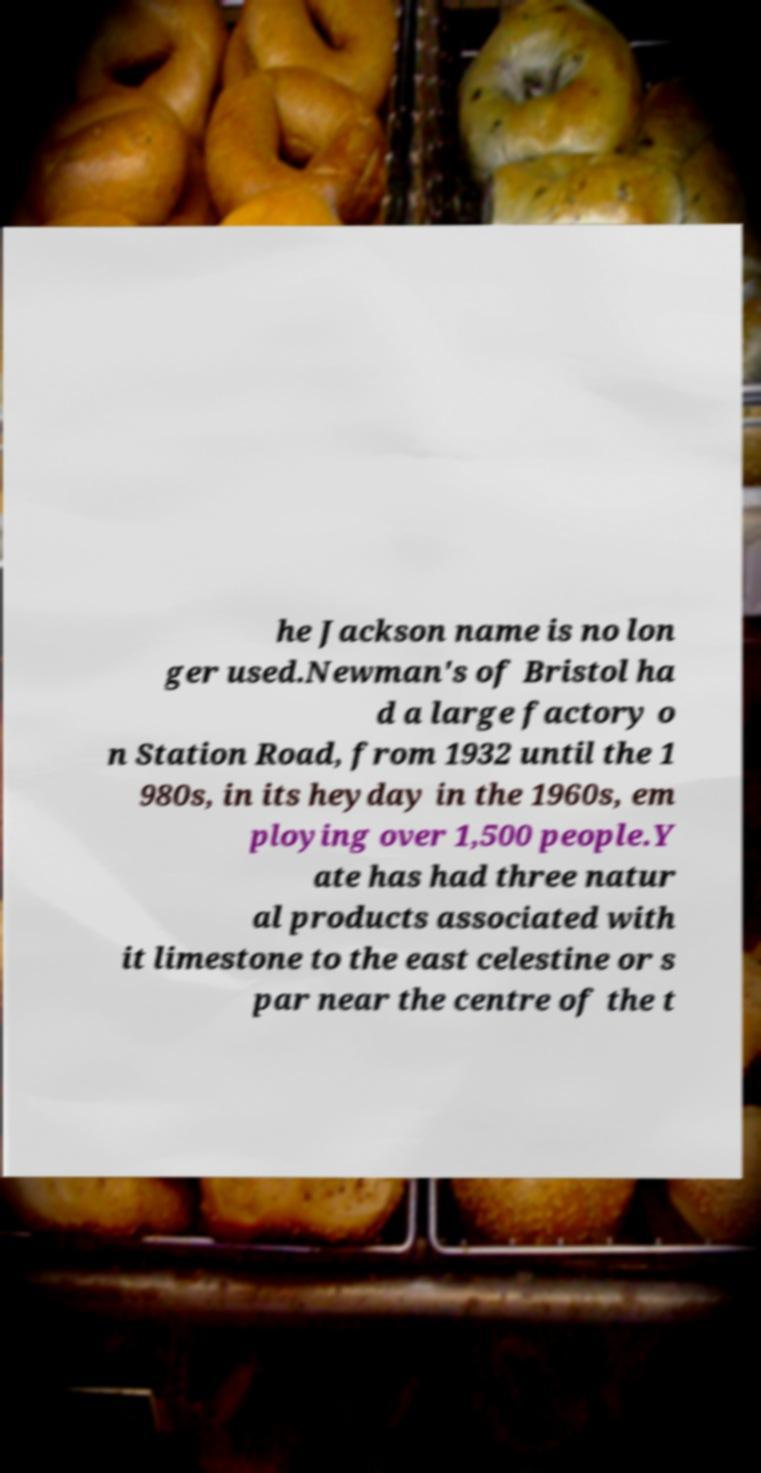Can you accurately transcribe the text from the provided image for me? he Jackson name is no lon ger used.Newman's of Bristol ha d a large factory o n Station Road, from 1932 until the 1 980s, in its heyday in the 1960s, em ploying over 1,500 people.Y ate has had three natur al products associated with it limestone to the east celestine or s par near the centre of the t 